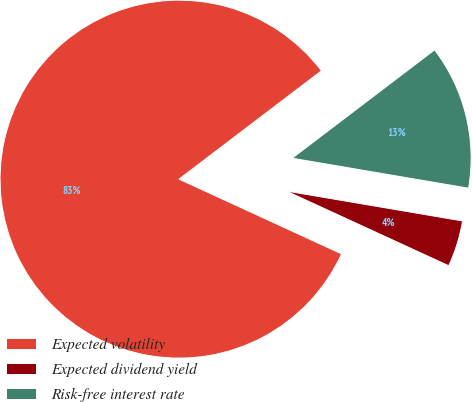Convert chart. <chart><loc_0><loc_0><loc_500><loc_500><pie_chart><fcel>Expected volatility<fcel>Expected dividend yield<fcel>Risk-free interest rate<nl><fcel>82.79%<fcel>4.18%<fcel>13.03%<nl></chart> 